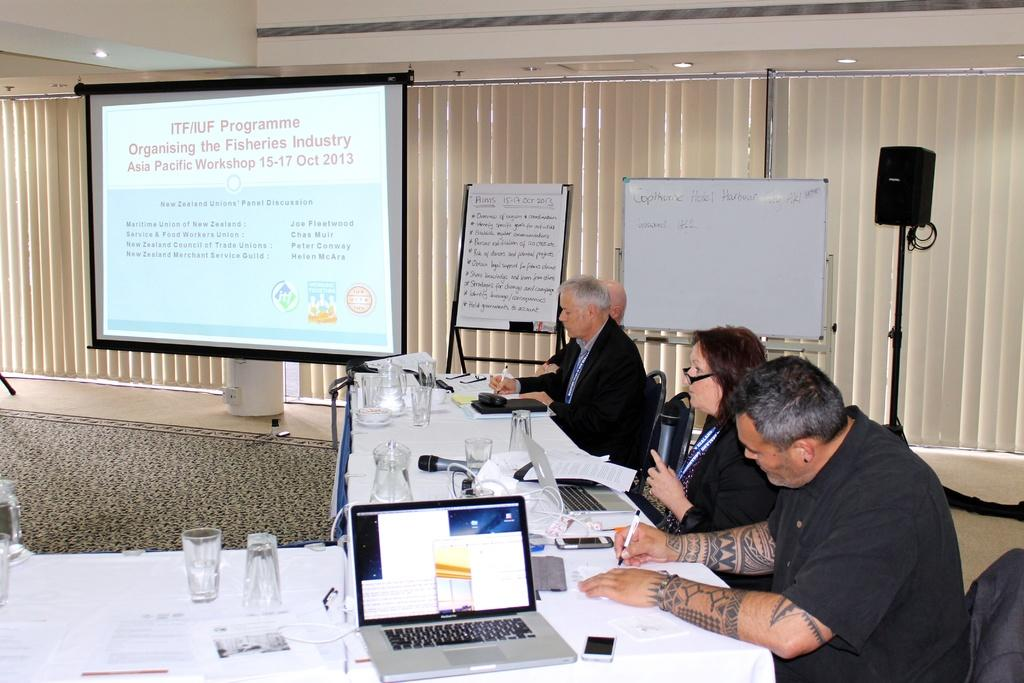<image>
Render a clear and concise summary of the photo. four people at a conference table and a screen showing info for the ITF/IUFProgramme 